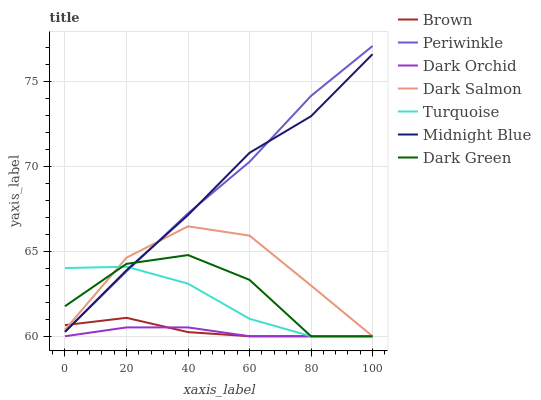Does Dark Orchid have the minimum area under the curve?
Answer yes or no. Yes. Does Periwinkle have the maximum area under the curve?
Answer yes or no. Yes. Does Turquoise have the minimum area under the curve?
Answer yes or no. No. Does Turquoise have the maximum area under the curve?
Answer yes or no. No. Is Dark Orchid the smoothest?
Answer yes or no. Yes. Is Dark Green the roughest?
Answer yes or no. Yes. Is Turquoise the smoothest?
Answer yes or no. No. Is Turquoise the roughest?
Answer yes or no. No. Does Brown have the lowest value?
Answer yes or no. Yes. Does Midnight Blue have the lowest value?
Answer yes or no. No. Does Periwinkle have the highest value?
Answer yes or no. Yes. Does Turquoise have the highest value?
Answer yes or no. No. Is Dark Orchid less than Midnight Blue?
Answer yes or no. Yes. Is Periwinkle greater than Dark Orchid?
Answer yes or no. Yes. Does Midnight Blue intersect Turquoise?
Answer yes or no. Yes. Is Midnight Blue less than Turquoise?
Answer yes or no. No. Is Midnight Blue greater than Turquoise?
Answer yes or no. No. Does Dark Orchid intersect Midnight Blue?
Answer yes or no. No. 